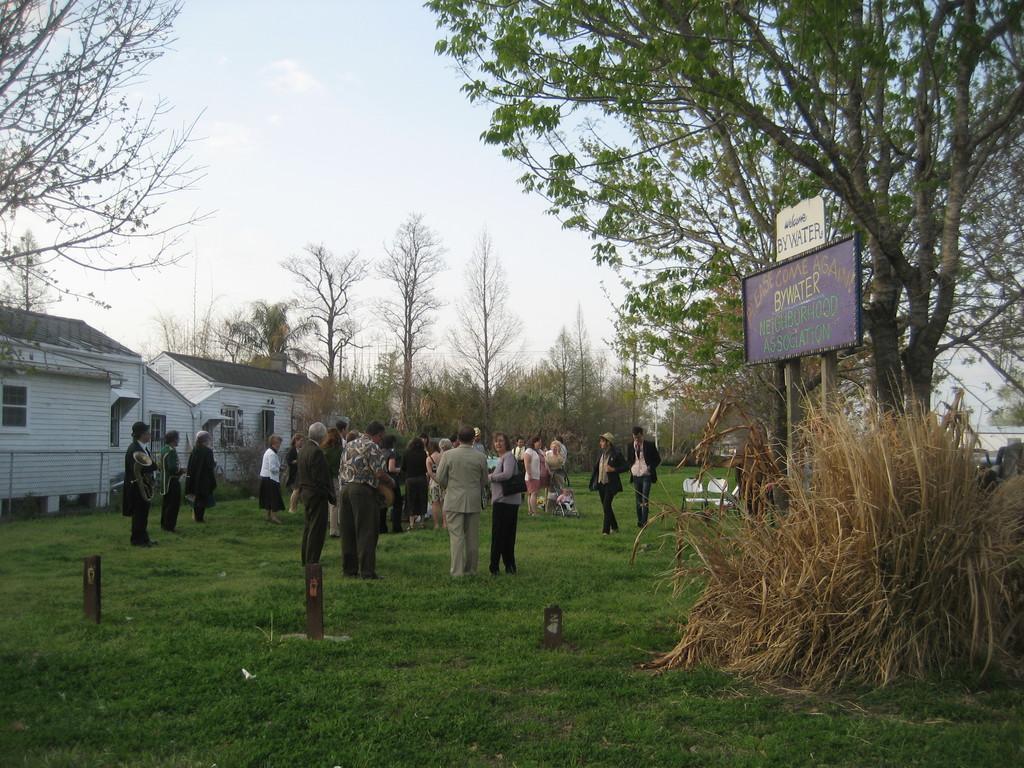Could you give a brief overview of what you see in this image? In this image there are a few people standing on the surface of the grass, behind the people there are houses and trees. 